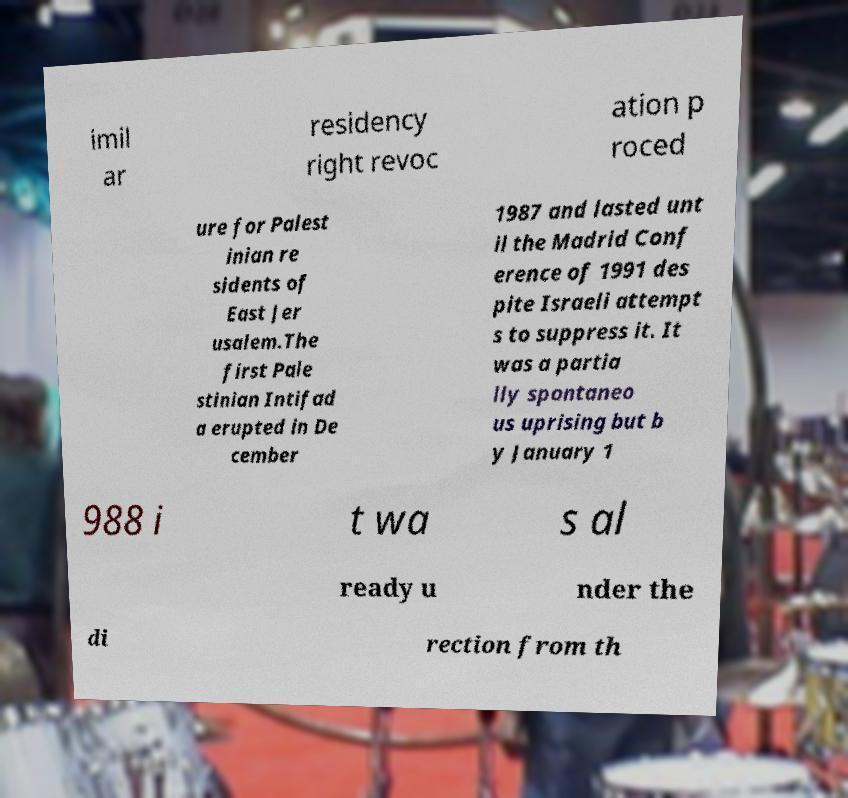For documentation purposes, I need the text within this image transcribed. Could you provide that? imil ar residency right revoc ation p roced ure for Palest inian re sidents of East Jer usalem.The first Pale stinian Intifad a erupted in De cember 1987 and lasted unt il the Madrid Conf erence of 1991 des pite Israeli attempt s to suppress it. It was a partia lly spontaneo us uprising but b y January 1 988 i t wa s al ready u nder the di rection from th 